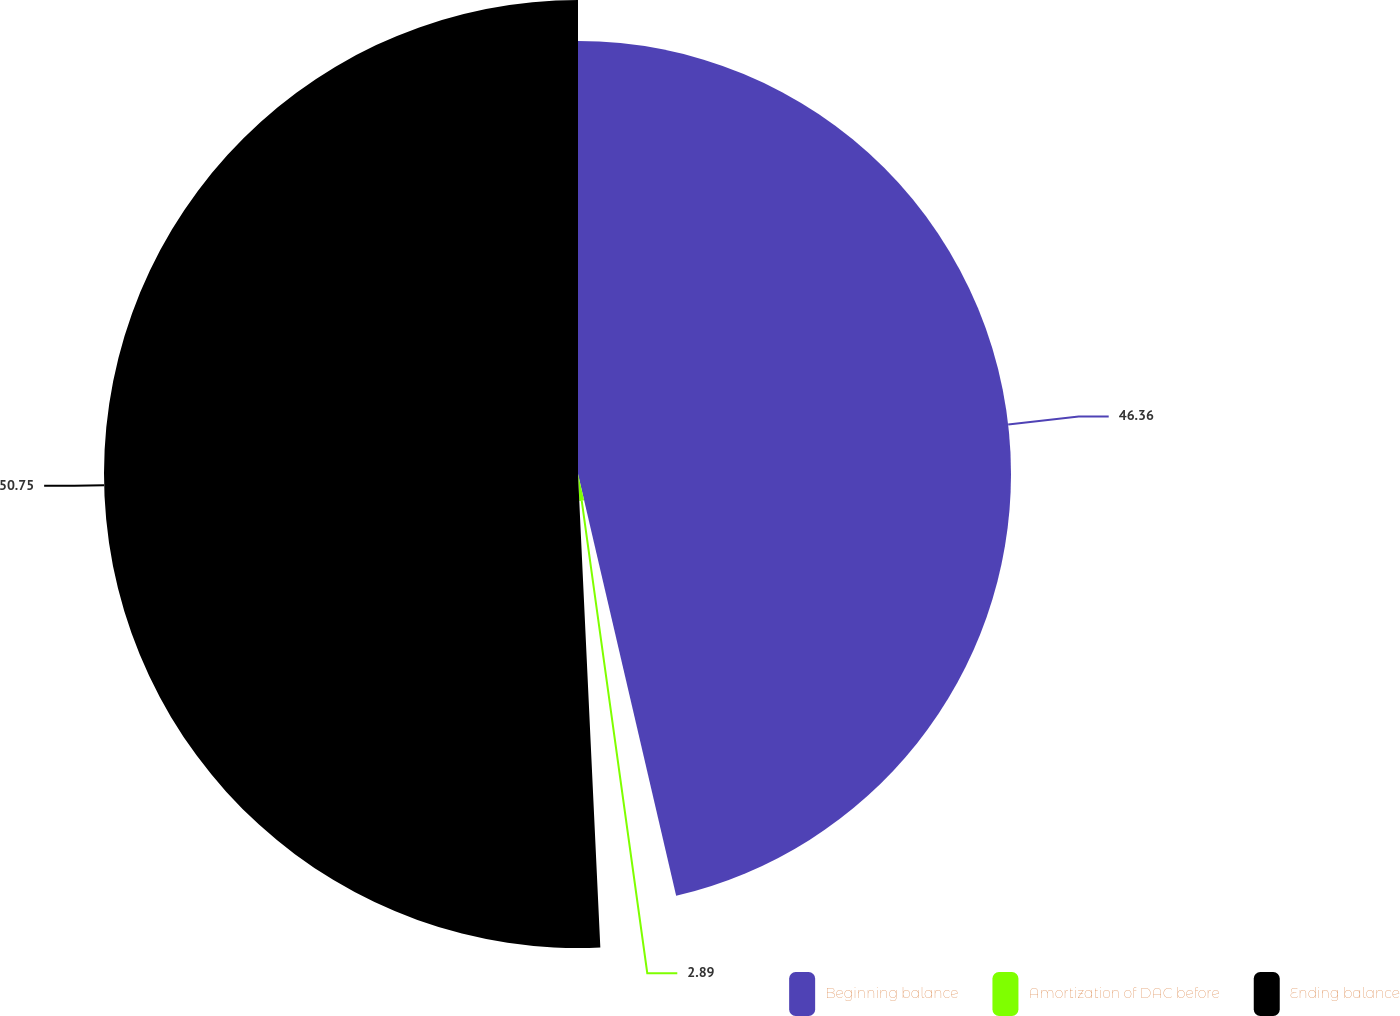Convert chart. <chart><loc_0><loc_0><loc_500><loc_500><pie_chart><fcel>Beginning balance<fcel>Amortization of DAC before<fcel>Ending balance<nl><fcel>46.36%<fcel>2.89%<fcel>50.75%<nl></chart> 